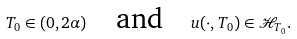<formula> <loc_0><loc_0><loc_500><loc_500>T _ { 0 } \in ( 0 , 2 \alpha ) \quad \text {and} \quad u ( \cdot , T _ { 0 } ) \in { \mathcal { H } } _ { T _ { 0 } } .</formula> 